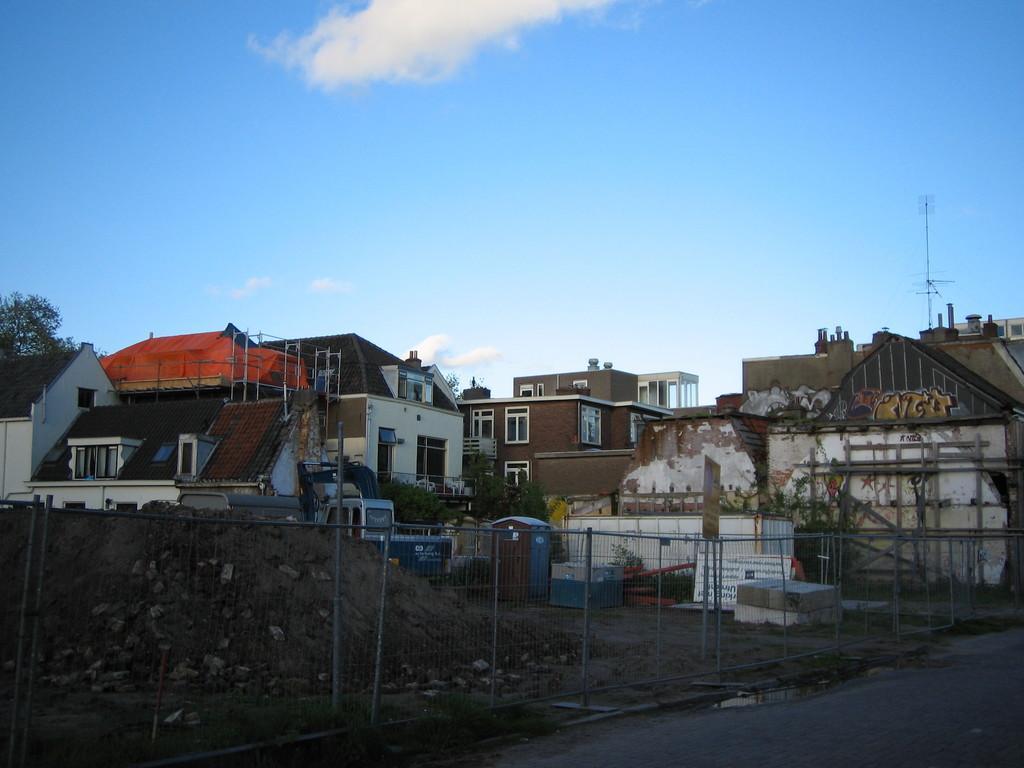Can you describe this image briefly? In the foreground of the picture we can see fencing, road, stones, sand, boxes, plants and various objects. In the middle of the picture there are building, trees, antenna and various objects. At the top it is sky. 